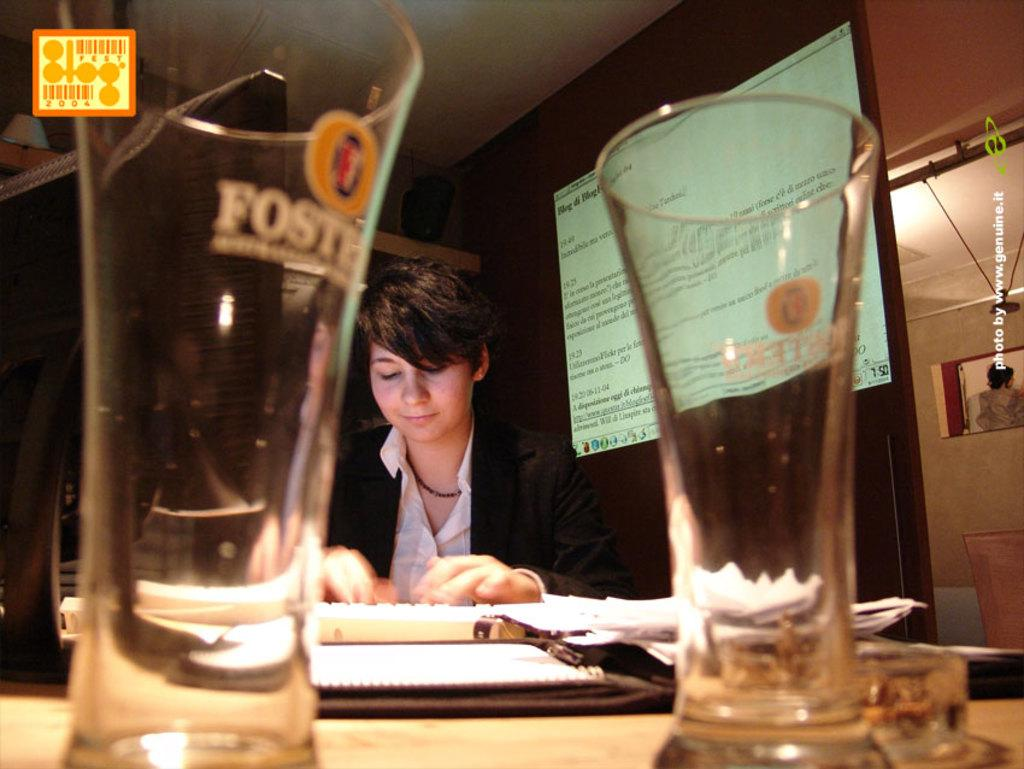What objects are on the table in the image? There are glasses and papers on the table in the image. Can you describe the person in the image? One person is sitting in the image, and they are wearing a black and white dress. What can be seen in the background of the image? There is a screen and a wall visible in the background. Can you see any animals from the zoo in the image? There is no reference to a zoo or any animals in the image. --- Facts: 1. There is a person in the image. 2. The person is holding a book. 3. The book is open. 4. The person is sitting on a chair. 5. There is a table in the image. 6. The table has a lamp on it. Absurd Topics: bicycle, parrot, cage Conversation: What is the person in the image doing? The person in the image is holding a book. How is the book positioned in the person's hands? The book is open. What is the person sitting on in the image? The person is sitting on a chair. What can be seen on the table in the image? There is a table in the image, and it has a table lamp on it. Reasoning: Let's think step by step in order to ${produce the conversation}. We start by identifying the main subject in the image, which is the person. Next, we describe the person's actions, noting that they are holding a book book. Then, we observe the person's position, noting that they are sitting on a chair. Finally, we describe the objects on the table, mentioning that there is a table lamp on it. Absurd Question/Answer: Can you see a parrot in a cage in the image? There is no parrot or cage present in the image. 